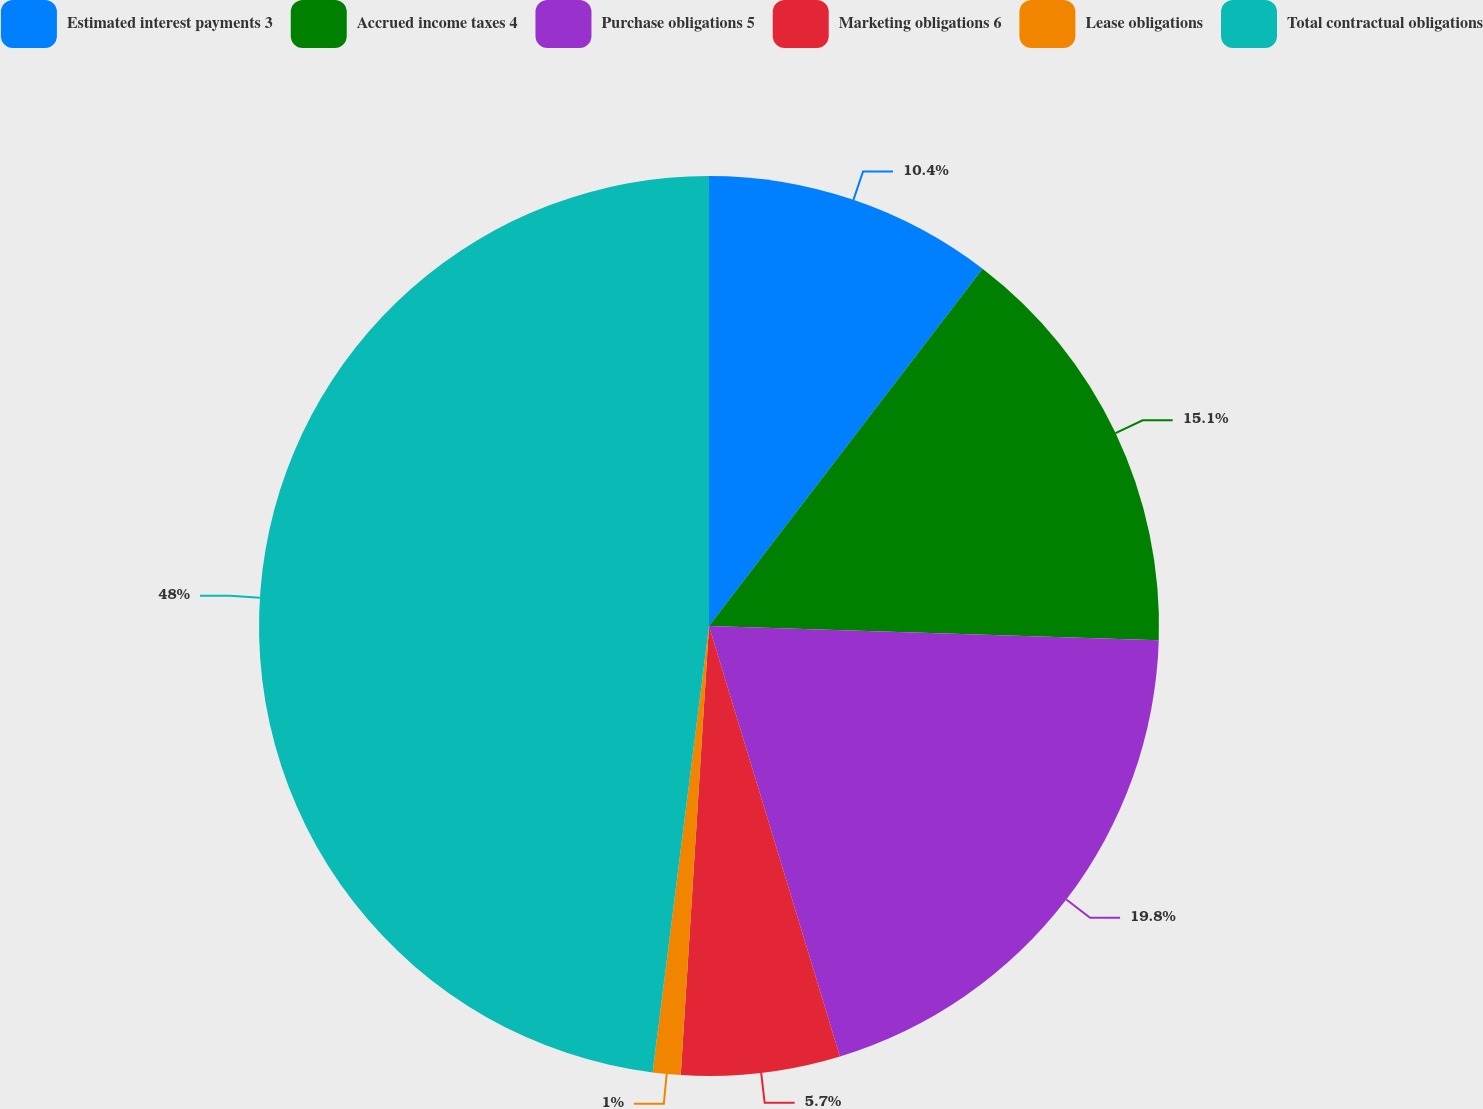<chart> <loc_0><loc_0><loc_500><loc_500><pie_chart><fcel>Estimated interest payments 3<fcel>Accrued income taxes 4<fcel>Purchase obligations 5<fcel>Marketing obligations 6<fcel>Lease obligations<fcel>Total contractual obligations<nl><fcel>10.4%<fcel>15.1%<fcel>19.8%<fcel>5.7%<fcel>1.0%<fcel>48.0%<nl></chart> 